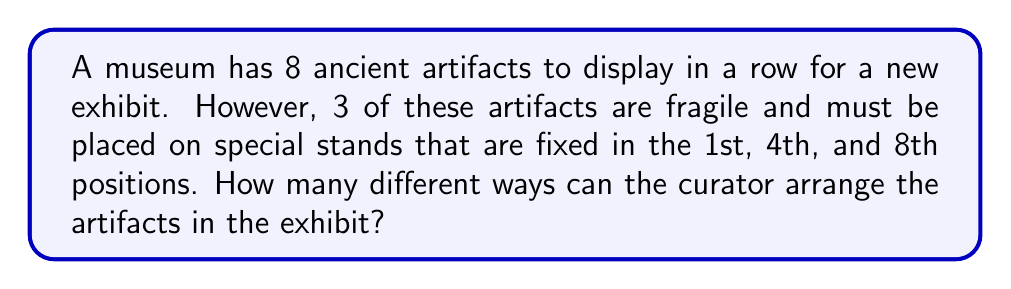Show me your answer to this math problem. Let's approach this step-by-step:

1) First, we need to understand that 3 positions (1st, 4th, and 8th) are already fixed for the fragile artifacts. This means we only need to arrange the remaining 5 artifacts in the 5 remaining positions.

2) For the 3 fixed positions, we need to choose which of the 3 fragile artifacts goes in each spot. This can be done in $3!$ (3 factorial) ways:
   
   $3! = 3 \times 2 \times 1 = 6$ ways

3) For the remaining 5 artifacts and 5 positions, we can arrange them in $5!$ ways:
   
   $5! = 5 \times 4 \times 3 \times 2 \times 1 = 120$ ways

4) By the multiplication principle, the total number of ways to arrange the artifacts is the product of the number of ways to arrange the fragile artifacts and the number of ways to arrange the remaining artifacts:

   $6 \times 120 = 720$ ways

Therefore, the curator can arrange the artifacts in 720 different ways.
Answer: 720 